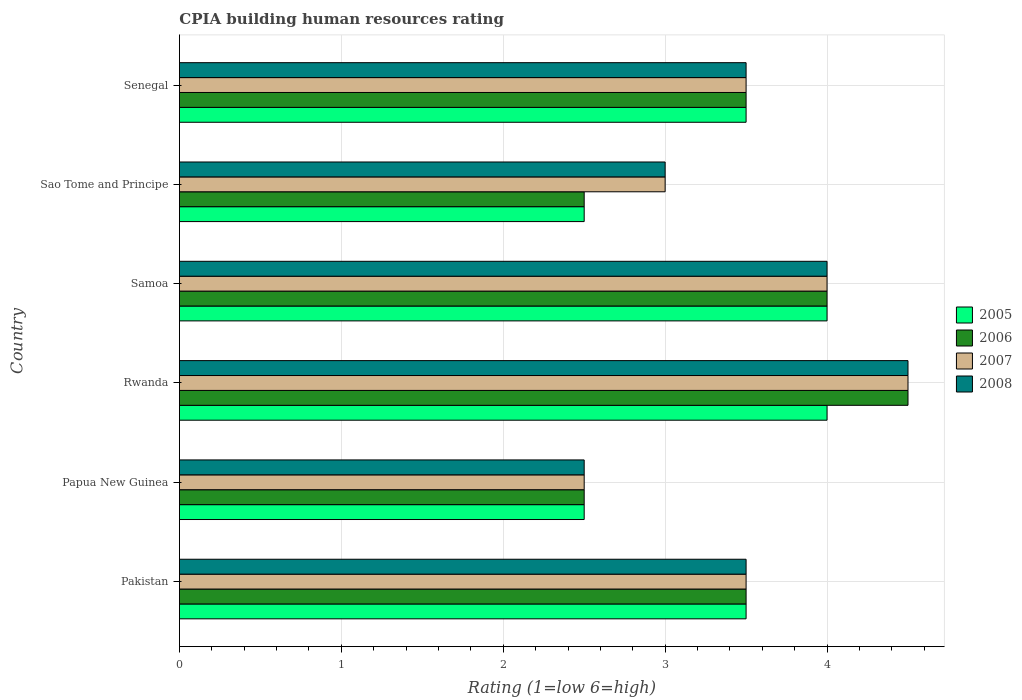How many groups of bars are there?
Ensure brevity in your answer.  6. How many bars are there on the 1st tick from the top?
Your answer should be very brief. 4. What is the label of the 4th group of bars from the top?
Provide a succinct answer. Rwanda. Across all countries, what is the maximum CPIA rating in 2008?
Make the answer very short. 4.5. In which country was the CPIA rating in 2006 maximum?
Your response must be concise. Rwanda. In which country was the CPIA rating in 2005 minimum?
Provide a succinct answer. Papua New Guinea. What is the difference between the CPIA rating in 2006 in Pakistan and that in Senegal?
Keep it short and to the point. 0. What is the average CPIA rating in 2006 per country?
Your answer should be very brief. 3.42. What is the difference between the CPIA rating in 2007 and CPIA rating in 2006 in Rwanda?
Provide a short and direct response. 0. In how many countries, is the CPIA rating in 2007 greater than the average CPIA rating in 2007 taken over all countries?
Ensure brevity in your answer.  2. Are all the bars in the graph horizontal?
Your response must be concise. Yes. How many countries are there in the graph?
Provide a short and direct response. 6. How are the legend labels stacked?
Make the answer very short. Vertical. What is the title of the graph?
Your answer should be very brief. CPIA building human resources rating. Does "1987" appear as one of the legend labels in the graph?
Your answer should be very brief. No. What is the label or title of the X-axis?
Your answer should be very brief. Rating (1=low 6=high). What is the label or title of the Y-axis?
Your answer should be compact. Country. What is the Rating (1=low 6=high) of 2008 in Pakistan?
Ensure brevity in your answer.  3.5. What is the Rating (1=low 6=high) in 2005 in Papua New Guinea?
Keep it short and to the point. 2.5. What is the Rating (1=low 6=high) in 2006 in Rwanda?
Make the answer very short. 4.5. What is the Rating (1=low 6=high) of 2007 in Rwanda?
Offer a very short reply. 4.5. What is the Rating (1=low 6=high) in 2005 in Samoa?
Your answer should be compact. 4. What is the Rating (1=low 6=high) in 2007 in Samoa?
Offer a terse response. 4. What is the Rating (1=low 6=high) of 2006 in Sao Tome and Principe?
Offer a very short reply. 2.5. What is the Rating (1=low 6=high) in 2007 in Sao Tome and Principe?
Provide a short and direct response. 3. What is the Rating (1=low 6=high) of 2008 in Sao Tome and Principe?
Provide a short and direct response. 3. What is the Rating (1=low 6=high) in 2006 in Senegal?
Offer a very short reply. 3.5. What is the Rating (1=low 6=high) of 2008 in Senegal?
Your response must be concise. 3.5. Across all countries, what is the maximum Rating (1=low 6=high) of 2005?
Offer a very short reply. 4. Across all countries, what is the maximum Rating (1=low 6=high) in 2006?
Ensure brevity in your answer.  4.5. What is the total Rating (1=low 6=high) of 2005 in the graph?
Provide a succinct answer. 20. What is the total Rating (1=low 6=high) in 2006 in the graph?
Make the answer very short. 20.5. What is the difference between the Rating (1=low 6=high) of 2006 in Pakistan and that in Papua New Guinea?
Make the answer very short. 1. What is the difference between the Rating (1=low 6=high) in 2007 in Pakistan and that in Papua New Guinea?
Your response must be concise. 1. What is the difference between the Rating (1=low 6=high) of 2005 in Pakistan and that in Rwanda?
Provide a short and direct response. -0.5. What is the difference between the Rating (1=low 6=high) in 2006 in Pakistan and that in Rwanda?
Your response must be concise. -1. What is the difference between the Rating (1=low 6=high) in 2008 in Pakistan and that in Samoa?
Provide a short and direct response. -0.5. What is the difference between the Rating (1=low 6=high) of 2006 in Pakistan and that in Sao Tome and Principe?
Keep it short and to the point. 1. What is the difference between the Rating (1=low 6=high) of 2008 in Pakistan and that in Sao Tome and Principe?
Offer a terse response. 0.5. What is the difference between the Rating (1=low 6=high) of 2006 in Pakistan and that in Senegal?
Ensure brevity in your answer.  0. What is the difference between the Rating (1=low 6=high) of 2008 in Pakistan and that in Senegal?
Your answer should be compact. 0. What is the difference between the Rating (1=low 6=high) in 2005 in Papua New Guinea and that in Rwanda?
Offer a terse response. -1.5. What is the difference between the Rating (1=low 6=high) of 2006 in Papua New Guinea and that in Rwanda?
Provide a succinct answer. -2. What is the difference between the Rating (1=low 6=high) in 2005 in Papua New Guinea and that in Samoa?
Your answer should be very brief. -1.5. What is the difference between the Rating (1=low 6=high) in 2007 in Papua New Guinea and that in Samoa?
Offer a very short reply. -1.5. What is the difference between the Rating (1=low 6=high) in 2008 in Papua New Guinea and that in Samoa?
Your response must be concise. -1.5. What is the difference between the Rating (1=low 6=high) in 2005 in Papua New Guinea and that in Sao Tome and Principe?
Make the answer very short. 0. What is the difference between the Rating (1=low 6=high) in 2005 in Papua New Guinea and that in Senegal?
Ensure brevity in your answer.  -1. What is the difference between the Rating (1=low 6=high) in 2008 in Papua New Guinea and that in Senegal?
Provide a succinct answer. -1. What is the difference between the Rating (1=low 6=high) in 2005 in Rwanda and that in Samoa?
Your response must be concise. 0. What is the difference between the Rating (1=low 6=high) in 2006 in Rwanda and that in Samoa?
Provide a short and direct response. 0.5. What is the difference between the Rating (1=low 6=high) of 2008 in Rwanda and that in Samoa?
Provide a short and direct response. 0.5. What is the difference between the Rating (1=low 6=high) of 2005 in Rwanda and that in Sao Tome and Principe?
Give a very brief answer. 1.5. What is the difference between the Rating (1=low 6=high) of 2006 in Rwanda and that in Sao Tome and Principe?
Provide a succinct answer. 2. What is the difference between the Rating (1=low 6=high) in 2007 in Rwanda and that in Sao Tome and Principe?
Provide a short and direct response. 1.5. What is the difference between the Rating (1=low 6=high) in 2008 in Rwanda and that in Sao Tome and Principe?
Provide a succinct answer. 1.5. What is the difference between the Rating (1=low 6=high) in 2006 in Rwanda and that in Senegal?
Offer a very short reply. 1. What is the difference between the Rating (1=low 6=high) of 2007 in Rwanda and that in Senegal?
Give a very brief answer. 1. What is the difference between the Rating (1=low 6=high) in 2006 in Samoa and that in Sao Tome and Principe?
Give a very brief answer. 1.5. What is the difference between the Rating (1=low 6=high) in 2007 in Samoa and that in Sao Tome and Principe?
Your answer should be very brief. 1. What is the difference between the Rating (1=low 6=high) in 2005 in Samoa and that in Senegal?
Keep it short and to the point. 0.5. What is the difference between the Rating (1=low 6=high) in 2006 in Samoa and that in Senegal?
Your answer should be compact. 0.5. What is the difference between the Rating (1=low 6=high) of 2008 in Samoa and that in Senegal?
Make the answer very short. 0.5. What is the difference between the Rating (1=low 6=high) of 2007 in Sao Tome and Principe and that in Senegal?
Your answer should be very brief. -0.5. What is the difference between the Rating (1=low 6=high) of 2005 in Pakistan and the Rating (1=low 6=high) of 2008 in Papua New Guinea?
Provide a succinct answer. 1. What is the difference between the Rating (1=low 6=high) of 2007 in Pakistan and the Rating (1=low 6=high) of 2008 in Papua New Guinea?
Offer a very short reply. 1. What is the difference between the Rating (1=low 6=high) of 2005 in Pakistan and the Rating (1=low 6=high) of 2006 in Rwanda?
Keep it short and to the point. -1. What is the difference between the Rating (1=low 6=high) of 2005 in Pakistan and the Rating (1=low 6=high) of 2008 in Rwanda?
Your response must be concise. -1. What is the difference between the Rating (1=low 6=high) of 2006 in Pakistan and the Rating (1=low 6=high) of 2008 in Rwanda?
Your answer should be very brief. -1. What is the difference between the Rating (1=low 6=high) in 2007 in Pakistan and the Rating (1=low 6=high) in 2008 in Rwanda?
Keep it short and to the point. -1. What is the difference between the Rating (1=low 6=high) of 2005 in Pakistan and the Rating (1=low 6=high) of 2007 in Samoa?
Ensure brevity in your answer.  -0.5. What is the difference between the Rating (1=low 6=high) in 2006 in Pakistan and the Rating (1=low 6=high) in 2007 in Samoa?
Offer a very short reply. -0.5. What is the difference between the Rating (1=low 6=high) of 2007 in Pakistan and the Rating (1=low 6=high) of 2008 in Samoa?
Provide a short and direct response. -0.5. What is the difference between the Rating (1=low 6=high) in 2005 in Pakistan and the Rating (1=low 6=high) in 2006 in Sao Tome and Principe?
Keep it short and to the point. 1. What is the difference between the Rating (1=low 6=high) in 2005 in Pakistan and the Rating (1=low 6=high) in 2008 in Sao Tome and Principe?
Make the answer very short. 0.5. What is the difference between the Rating (1=low 6=high) of 2007 in Pakistan and the Rating (1=low 6=high) of 2008 in Sao Tome and Principe?
Give a very brief answer. 0.5. What is the difference between the Rating (1=low 6=high) of 2005 in Pakistan and the Rating (1=low 6=high) of 2008 in Senegal?
Your response must be concise. 0. What is the difference between the Rating (1=low 6=high) in 2006 in Pakistan and the Rating (1=low 6=high) in 2007 in Senegal?
Offer a terse response. 0. What is the difference between the Rating (1=low 6=high) in 2007 in Pakistan and the Rating (1=low 6=high) in 2008 in Senegal?
Your answer should be very brief. 0. What is the difference between the Rating (1=low 6=high) of 2005 in Papua New Guinea and the Rating (1=low 6=high) of 2006 in Rwanda?
Keep it short and to the point. -2. What is the difference between the Rating (1=low 6=high) in 2005 in Papua New Guinea and the Rating (1=low 6=high) in 2007 in Rwanda?
Give a very brief answer. -2. What is the difference between the Rating (1=low 6=high) in 2006 in Papua New Guinea and the Rating (1=low 6=high) in 2008 in Rwanda?
Ensure brevity in your answer.  -2. What is the difference between the Rating (1=low 6=high) of 2007 in Papua New Guinea and the Rating (1=low 6=high) of 2008 in Rwanda?
Provide a short and direct response. -2. What is the difference between the Rating (1=low 6=high) in 2005 in Papua New Guinea and the Rating (1=low 6=high) in 2006 in Samoa?
Ensure brevity in your answer.  -1.5. What is the difference between the Rating (1=low 6=high) in 2005 in Papua New Guinea and the Rating (1=low 6=high) in 2008 in Samoa?
Give a very brief answer. -1.5. What is the difference between the Rating (1=low 6=high) of 2005 in Papua New Guinea and the Rating (1=low 6=high) of 2006 in Senegal?
Ensure brevity in your answer.  -1. What is the difference between the Rating (1=low 6=high) in 2005 in Papua New Guinea and the Rating (1=low 6=high) in 2007 in Senegal?
Your answer should be compact. -1. What is the difference between the Rating (1=low 6=high) in 2005 in Papua New Guinea and the Rating (1=low 6=high) in 2008 in Senegal?
Offer a terse response. -1. What is the difference between the Rating (1=low 6=high) of 2007 in Papua New Guinea and the Rating (1=low 6=high) of 2008 in Senegal?
Your response must be concise. -1. What is the difference between the Rating (1=low 6=high) of 2005 in Rwanda and the Rating (1=low 6=high) of 2006 in Samoa?
Your answer should be compact. 0. What is the difference between the Rating (1=low 6=high) of 2005 in Rwanda and the Rating (1=low 6=high) of 2007 in Samoa?
Provide a succinct answer. 0. What is the difference between the Rating (1=low 6=high) in 2005 in Rwanda and the Rating (1=low 6=high) in 2008 in Samoa?
Provide a short and direct response. 0. What is the difference between the Rating (1=low 6=high) of 2006 in Rwanda and the Rating (1=low 6=high) of 2008 in Samoa?
Your response must be concise. 0.5. What is the difference between the Rating (1=low 6=high) in 2007 in Rwanda and the Rating (1=low 6=high) in 2008 in Samoa?
Your answer should be compact. 0.5. What is the difference between the Rating (1=low 6=high) of 2005 in Rwanda and the Rating (1=low 6=high) of 2007 in Sao Tome and Principe?
Offer a very short reply. 1. What is the difference between the Rating (1=low 6=high) in 2006 in Rwanda and the Rating (1=low 6=high) in 2008 in Sao Tome and Principe?
Ensure brevity in your answer.  1.5. What is the difference between the Rating (1=low 6=high) in 2005 in Rwanda and the Rating (1=low 6=high) in 2007 in Senegal?
Provide a succinct answer. 0.5. What is the difference between the Rating (1=low 6=high) of 2005 in Rwanda and the Rating (1=low 6=high) of 2008 in Senegal?
Keep it short and to the point. 0.5. What is the difference between the Rating (1=low 6=high) of 2006 in Rwanda and the Rating (1=low 6=high) of 2008 in Senegal?
Make the answer very short. 1. What is the difference between the Rating (1=low 6=high) of 2007 in Rwanda and the Rating (1=low 6=high) of 2008 in Senegal?
Provide a succinct answer. 1. What is the difference between the Rating (1=low 6=high) in 2005 in Samoa and the Rating (1=low 6=high) in 2007 in Sao Tome and Principe?
Provide a short and direct response. 1. What is the difference between the Rating (1=low 6=high) in 2006 in Samoa and the Rating (1=low 6=high) in 2007 in Sao Tome and Principe?
Your answer should be compact. 1. What is the difference between the Rating (1=low 6=high) in 2006 in Samoa and the Rating (1=low 6=high) in 2008 in Sao Tome and Principe?
Give a very brief answer. 1. What is the difference between the Rating (1=low 6=high) of 2007 in Samoa and the Rating (1=low 6=high) of 2008 in Sao Tome and Principe?
Offer a very short reply. 1. What is the difference between the Rating (1=low 6=high) in 2005 in Samoa and the Rating (1=low 6=high) in 2007 in Senegal?
Offer a terse response. 0.5. What is the difference between the Rating (1=low 6=high) in 2006 in Samoa and the Rating (1=low 6=high) in 2008 in Senegal?
Keep it short and to the point. 0.5. What is the difference between the Rating (1=low 6=high) of 2007 in Samoa and the Rating (1=low 6=high) of 2008 in Senegal?
Offer a terse response. 0.5. What is the difference between the Rating (1=low 6=high) of 2005 in Sao Tome and Principe and the Rating (1=low 6=high) of 2007 in Senegal?
Your answer should be very brief. -1. What is the difference between the Rating (1=low 6=high) in 2005 in Sao Tome and Principe and the Rating (1=low 6=high) in 2008 in Senegal?
Ensure brevity in your answer.  -1. What is the difference between the Rating (1=low 6=high) in 2006 in Sao Tome and Principe and the Rating (1=low 6=high) in 2007 in Senegal?
Make the answer very short. -1. What is the average Rating (1=low 6=high) in 2005 per country?
Provide a short and direct response. 3.33. What is the average Rating (1=low 6=high) of 2006 per country?
Offer a terse response. 3.42. What is the average Rating (1=low 6=high) of 2007 per country?
Offer a terse response. 3.5. What is the average Rating (1=low 6=high) of 2008 per country?
Offer a terse response. 3.5. What is the difference between the Rating (1=low 6=high) of 2005 and Rating (1=low 6=high) of 2006 in Pakistan?
Give a very brief answer. 0. What is the difference between the Rating (1=low 6=high) in 2005 and Rating (1=low 6=high) in 2007 in Pakistan?
Provide a succinct answer. 0. What is the difference between the Rating (1=low 6=high) in 2007 and Rating (1=low 6=high) in 2008 in Pakistan?
Offer a very short reply. 0. What is the difference between the Rating (1=low 6=high) of 2005 and Rating (1=low 6=high) of 2006 in Papua New Guinea?
Your response must be concise. 0. What is the difference between the Rating (1=low 6=high) in 2006 and Rating (1=low 6=high) in 2007 in Papua New Guinea?
Keep it short and to the point. 0. What is the difference between the Rating (1=low 6=high) in 2007 and Rating (1=low 6=high) in 2008 in Papua New Guinea?
Make the answer very short. 0. What is the difference between the Rating (1=low 6=high) in 2005 and Rating (1=low 6=high) in 2006 in Rwanda?
Give a very brief answer. -0.5. What is the difference between the Rating (1=low 6=high) of 2005 and Rating (1=low 6=high) of 2008 in Samoa?
Keep it short and to the point. 0. What is the difference between the Rating (1=low 6=high) of 2006 and Rating (1=low 6=high) of 2007 in Samoa?
Give a very brief answer. 0. What is the difference between the Rating (1=low 6=high) of 2006 and Rating (1=low 6=high) of 2008 in Samoa?
Make the answer very short. 0. What is the difference between the Rating (1=low 6=high) in 2007 and Rating (1=low 6=high) in 2008 in Samoa?
Make the answer very short. 0. What is the difference between the Rating (1=low 6=high) of 2005 and Rating (1=low 6=high) of 2006 in Sao Tome and Principe?
Offer a very short reply. 0. What is the difference between the Rating (1=low 6=high) in 2005 and Rating (1=low 6=high) in 2007 in Sao Tome and Principe?
Provide a succinct answer. -0.5. What is the difference between the Rating (1=low 6=high) of 2005 and Rating (1=low 6=high) of 2006 in Senegal?
Keep it short and to the point. 0. What is the difference between the Rating (1=low 6=high) of 2005 and Rating (1=low 6=high) of 2007 in Senegal?
Your response must be concise. 0. What is the ratio of the Rating (1=low 6=high) in 2007 in Pakistan to that in Papua New Guinea?
Offer a terse response. 1.4. What is the ratio of the Rating (1=low 6=high) in 2005 in Pakistan to that in Rwanda?
Your answer should be very brief. 0.88. What is the ratio of the Rating (1=low 6=high) of 2007 in Pakistan to that in Rwanda?
Ensure brevity in your answer.  0.78. What is the ratio of the Rating (1=low 6=high) in 2008 in Pakistan to that in Rwanda?
Make the answer very short. 0.78. What is the ratio of the Rating (1=low 6=high) in 2006 in Pakistan to that in Samoa?
Make the answer very short. 0.88. What is the ratio of the Rating (1=low 6=high) in 2006 in Pakistan to that in Sao Tome and Principe?
Your response must be concise. 1.4. What is the ratio of the Rating (1=low 6=high) in 2005 in Pakistan to that in Senegal?
Your response must be concise. 1. What is the ratio of the Rating (1=low 6=high) of 2006 in Pakistan to that in Senegal?
Make the answer very short. 1. What is the ratio of the Rating (1=low 6=high) in 2008 in Pakistan to that in Senegal?
Offer a terse response. 1. What is the ratio of the Rating (1=low 6=high) of 2006 in Papua New Guinea to that in Rwanda?
Your response must be concise. 0.56. What is the ratio of the Rating (1=low 6=high) of 2007 in Papua New Guinea to that in Rwanda?
Give a very brief answer. 0.56. What is the ratio of the Rating (1=low 6=high) in 2008 in Papua New Guinea to that in Rwanda?
Provide a short and direct response. 0.56. What is the ratio of the Rating (1=low 6=high) of 2006 in Papua New Guinea to that in Samoa?
Give a very brief answer. 0.62. What is the ratio of the Rating (1=low 6=high) in 2008 in Papua New Guinea to that in Samoa?
Provide a short and direct response. 0.62. What is the ratio of the Rating (1=low 6=high) in 2005 in Papua New Guinea to that in Sao Tome and Principe?
Provide a succinct answer. 1. What is the ratio of the Rating (1=low 6=high) in 2006 in Papua New Guinea to that in Sao Tome and Principe?
Your response must be concise. 1. What is the ratio of the Rating (1=low 6=high) in 2007 in Papua New Guinea to that in Sao Tome and Principe?
Provide a short and direct response. 0.83. What is the ratio of the Rating (1=low 6=high) in 2008 in Papua New Guinea to that in Senegal?
Offer a terse response. 0.71. What is the ratio of the Rating (1=low 6=high) in 2005 in Rwanda to that in Sao Tome and Principe?
Ensure brevity in your answer.  1.6. What is the ratio of the Rating (1=low 6=high) in 2006 in Rwanda to that in Sao Tome and Principe?
Offer a very short reply. 1.8. What is the ratio of the Rating (1=low 6=high) of 2008 in Rwanda to that in Sao Tome and Principe?
Ensure brevity in your answer.  1.5. What is the ratio of the Rating (1=low 6=high) of 2006 in Rwanda to that in Senegal?
Offer a very short reply. 1.29. What is the ratio of the Rating (1=low 6=high) of 2007 in Rwanda to that in Senegal?
Offer a terse response. 1.29. What is the ratio of the Rating (1=low 6=high) in 2008 in Rwanda to that in Senegal?
Give a very brief answer. 1.29. What is the ratio of the Rating (1=low 6=high) in 2006 in Samoa to that in Sao Tome and Principe?
Your response must be concise. 1.6. What is the ratio of the Rating (1=low 6=high) in 2008 in Samoa to that in Sao Tome and Principe?
Provide a short and direct response. 1.33. What is the ratio of the Rating (1=low 6=high) of 2007 in Samoa to that in Senegal?
Provide a succinct answer. 1.14. What is the ratio of the Rating (1=low 6=high) of 2008 in Samoa to that in Senegal?
Your response must be concise. 1.14. What is the ratio of the Rating (1=low 6=high) of 2005 in Sao Tome and Principe to that in Senegal?
Offer a very short reply. 0.71. What is the ratio of the Rating (1=low 6=high) in 2006 in Sao Tome and Principe to that in Senegal?
Offer a very short reply. 0.71. What is the ratio of the Rating (1=low 6=high) in 2008 in Sao Tome and Principe to that in Senegal?
Make the answer very short. 0.86. What is the difference between the highest and the second highest Rating (1=low 6=high) of 2007?
Offer a terse response. 0.5. What is the difference between the highest and the second highest Rating (1=low 6=high) in 2008?
Offer a terse response. 0.5. What is the difference between the highest and the lowest Rating (1=low 6=high) in 2005?
Ensure brevity in your answer.  1.5. What is the difference between the highest and the lowest Rating (1=low 6=high) in 2008?
Ensure brevity in your answer.  2. 